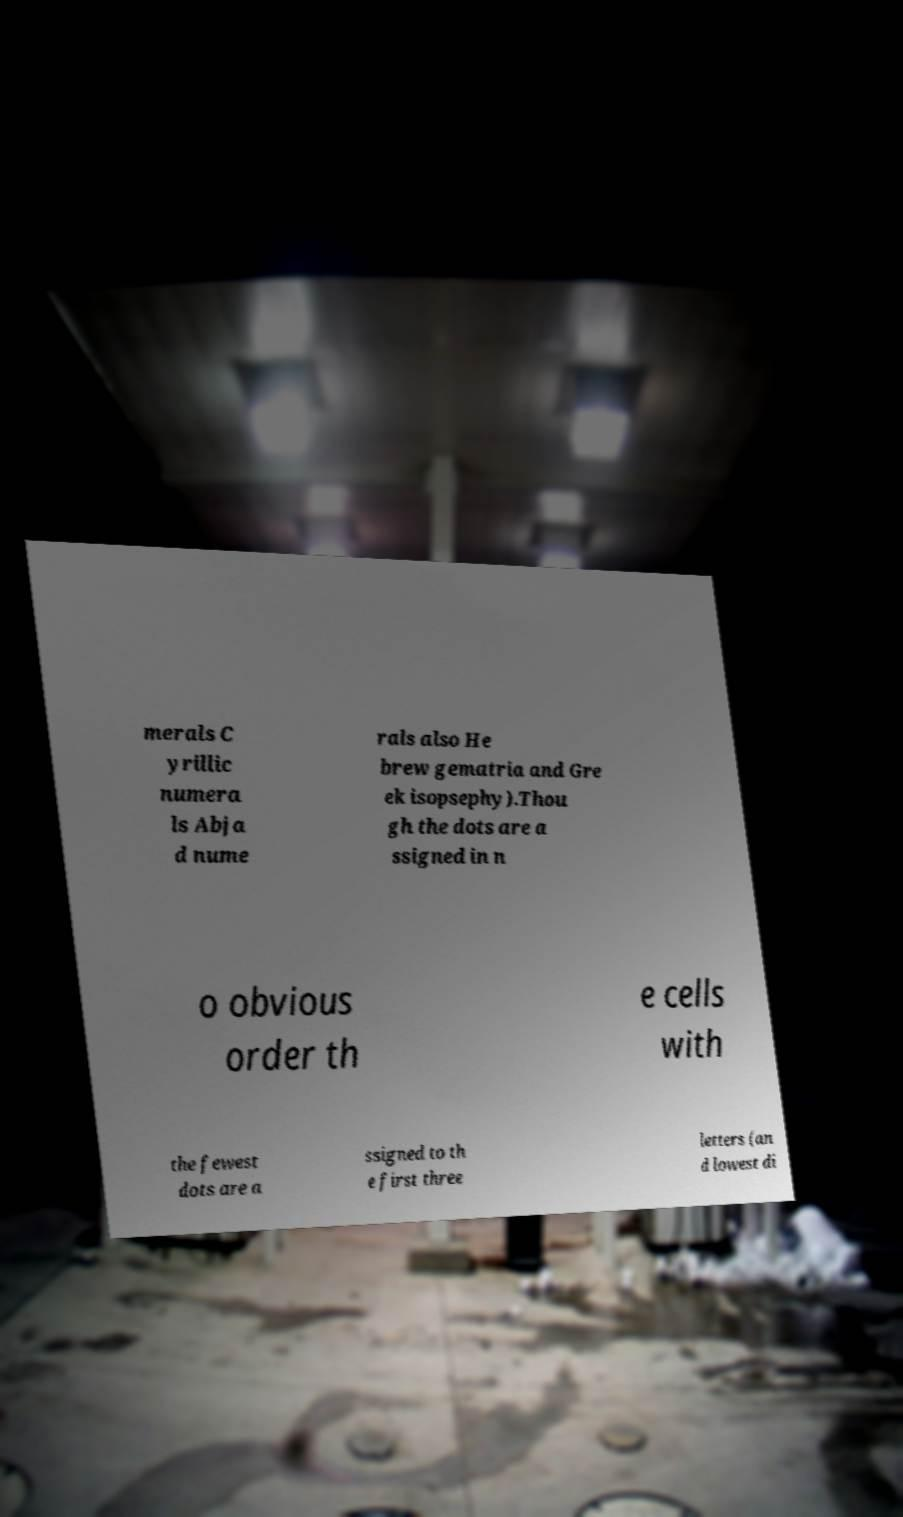I need the written content from this picture converted into text. Can you do that? merals C yrillic numera ls Abja d nume rals also He brew gematria and Gre ek isopsephy).Thou gh the dots are a ssigned in n o obvious order th e cells with the fewest dots are a ssigned to th e first three letters (an d lowest di 